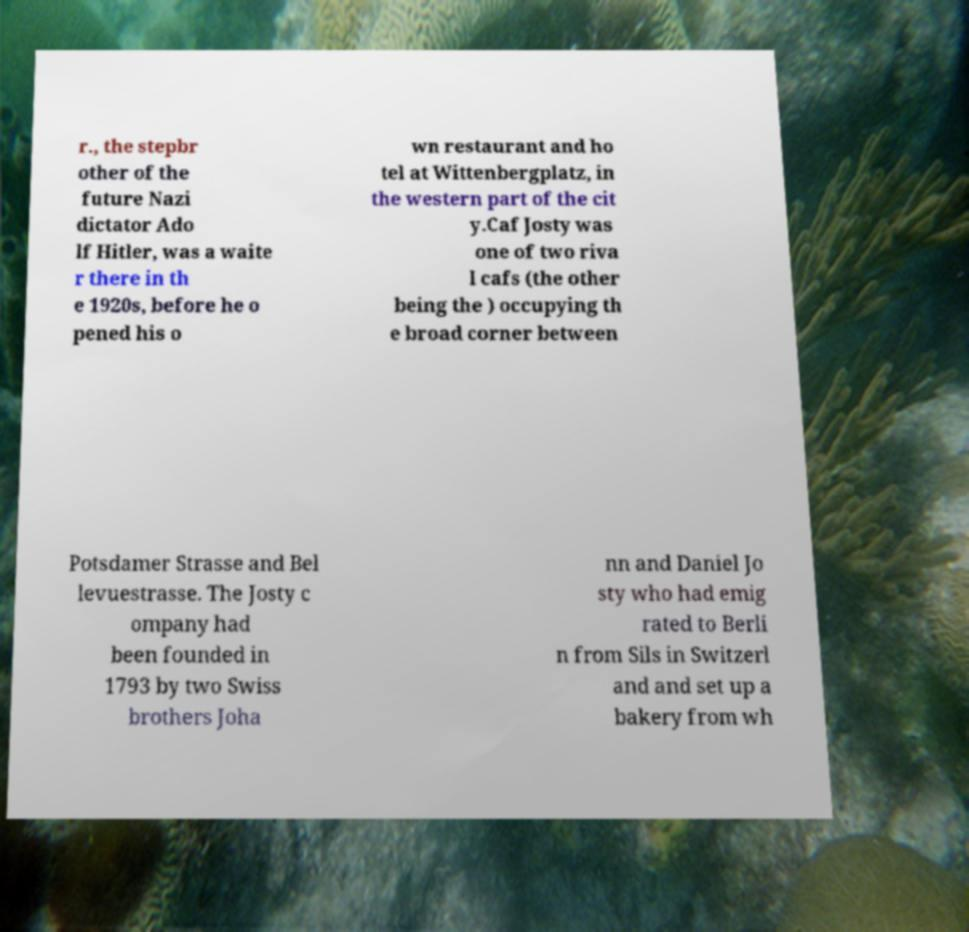What messages or text are displayed in this image? I need them in a readable, typed format. r., the stepbr other of the future Nazi dictator Ado lf Hitler, was a waite r there in th e 1920s, before he o pened his o wn restaurant and ho tel at Wittenbergplatz, in the western part of the cit y.Caf Josty was one of two riva l cafs (the other being the ) occupying th e broad corner between Potsdamer Strasse and Bel levuestrasse. The Josty c ompany had been founded in 1793 by two Swiss brothers Joha nn and Daniel Jo sty who had emig rated to Berli n from Sils in Switzerl and and set up a bakery from wh 